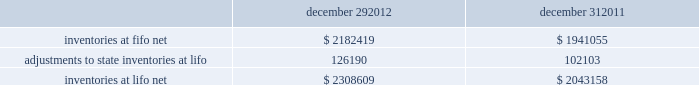In june 2011 , the fasb issued asu no .
2011-05 201ccomprehensive income 2013 presentation of comprehensive income . 201d asu 2011-05 requires comprehensive income , the components of net income , and the components of other comprehensive income either in a single continuous statement of comprehensive income or in two separate but consecutive statements .
In both choices , an entity is required to present each component of net income along with total net income , each component of other comprehensive income along with a total for other comprehensive income , and a total amount for comprehensive income .
This update eliminates the option to present the components of other comprehensive income as part of the statement of changes in stockholders' equity .
The amendments in this update do not change the items that must be reported in other comprehensive income or when an item of other comprehensive income must be reclassified to net income .
The amendments in this update should be applied retrospectively and is effective for interim and annual reporting periods beginning after december 15 , 2011 .
The company adopted this guidance in the first quarter of 2012 .
The adoption of asu 2011-05 is for presentation purposes only and had no material impact on the company 2019s consolidated financial statements .
Inventories , net : merchandise inventory the company used the lifo method of accounting for approximately 95% ( 95 % ) of inventories at both december 29 , 2012 and december 31 , 2011 .
Under lifo , the company 2019s cost of sales reflects the costs of the most recently purchased inventories , while the inventory carrying balance represents the costs for inventories purchased in fiscal 2012 and prior years .
The company recorded a reduction to cost of sales of $ 24087 and $ 29554 in fiscal 2012 and fiscal 2010 , respectively .
As a result of utilizing lifo , the company recorded an increase to cost of sales of $ 24708 for fiscal 2011 , due to an increase in supply chain costs and inflationary pressures affecting certain product categories .
The company 2019s overall costs to acquire inventory for the same or similar products have generally decreased historically as the company has been able to leverage its continued growth , execution of merchandise strategies and realization of supply chain efficiencies .
Product cores the remaining inventories are comprised of product cores , the non-consumable portion of certain parts and batteries , which are valued under the first-in , first-out ( "fifo" ) method .
Product cores are included as part of the company's merchandise costs and are either passed on to the customer or returned to the vendor .
Because product cores are not subject to frequent cost changes like the company's other merchandise inventory , there is no material difference when applying either the lifo or fifo valuation method .
Inventory overhead costs purchasing and warehousing costs included in inventory at december 29 , 2012 and december 31 , 2011 , were $ 134258 and $ 126840 , respectively .
Inventory balance and inventory reserves inventory balances at the end of fiscal 2012 and 2011 were as follows : december 29 , december 31 .
Inventory quantities are tracked through a perpetual inventory system .
The company completes physical inventories and other targeted inventory counts in its store locations to ensure the accuracy of the perpetual inventory quantities of both merchandise and core inventory in these locations .
In its distribution centers and pdq aes , the company uses a cycle counting program to ensure the accuracy of the perpetual inventory quantities of both merchandise and product core inventory .
Reserves advance auto parts , inc .
And subsidiaries notes to the consolidated financial statements december 29 , 2012 , december 31 , 2011 and january 1 , 2011 ( in thousands , except per share data ) .
What percent did the inventories at lifo net increase from the beginning of 2011 to the end of 2012? 
Rationale: to find the percentage change one must take the inventories at lifo net of 2012 and subtract it from the inventories at lifo net of 2011 . then take the answer and divide it by the inventories at lifo net of 2011 .
Computations: ((2308609 - 1941055) / 1941055)
Answer: 0.18936. 